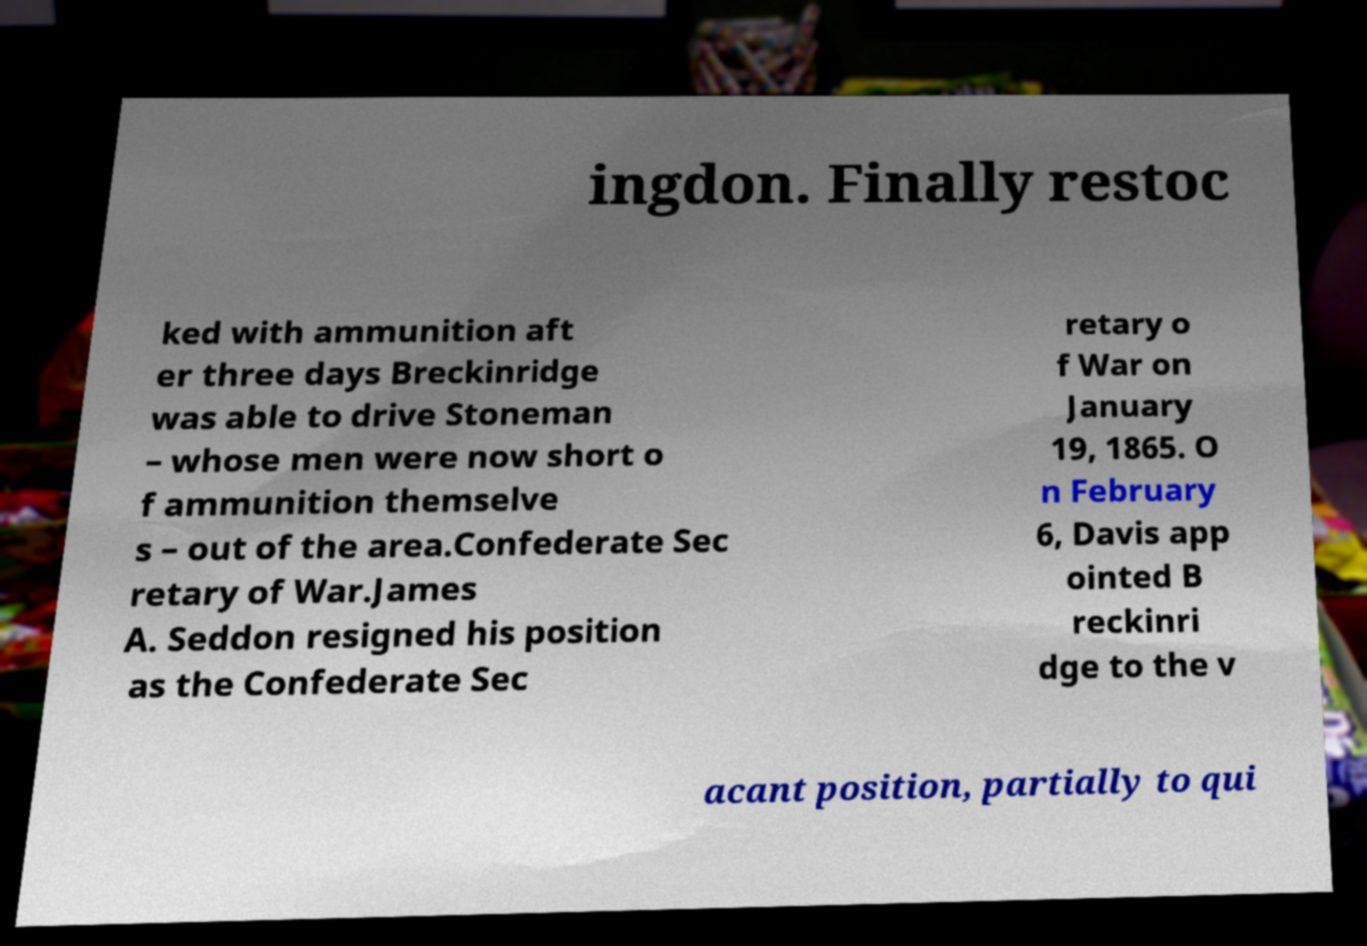I need the written content from this picture converted into text. Can you do that? ingdon. Finally restoc ked with ammunition aft er three days Breckinridge was able to drive Stoneman – whose men were now short o f ammunition themselve s – out of the area.Confederate Sec retary of War.James A. Seddon resigned his position as the Confederate Sec retary o f War on January 19, 1865. O n February 6, Davis app ointed B reckinri dge to the v acant position, partially to qui 